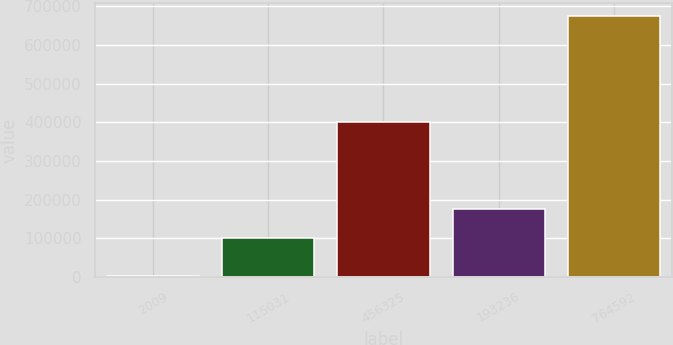Convert chart. <chart><loc_0><loc_0><loc_500><loc_500><bar_chart><fcel>2009<fcel>115031<fcel>456325<fcel>193236<fcel>764592<nl><fcel>2008<fcel>99449<fcel>400517<fcel>175086<fcel>675052<nl></chart> 